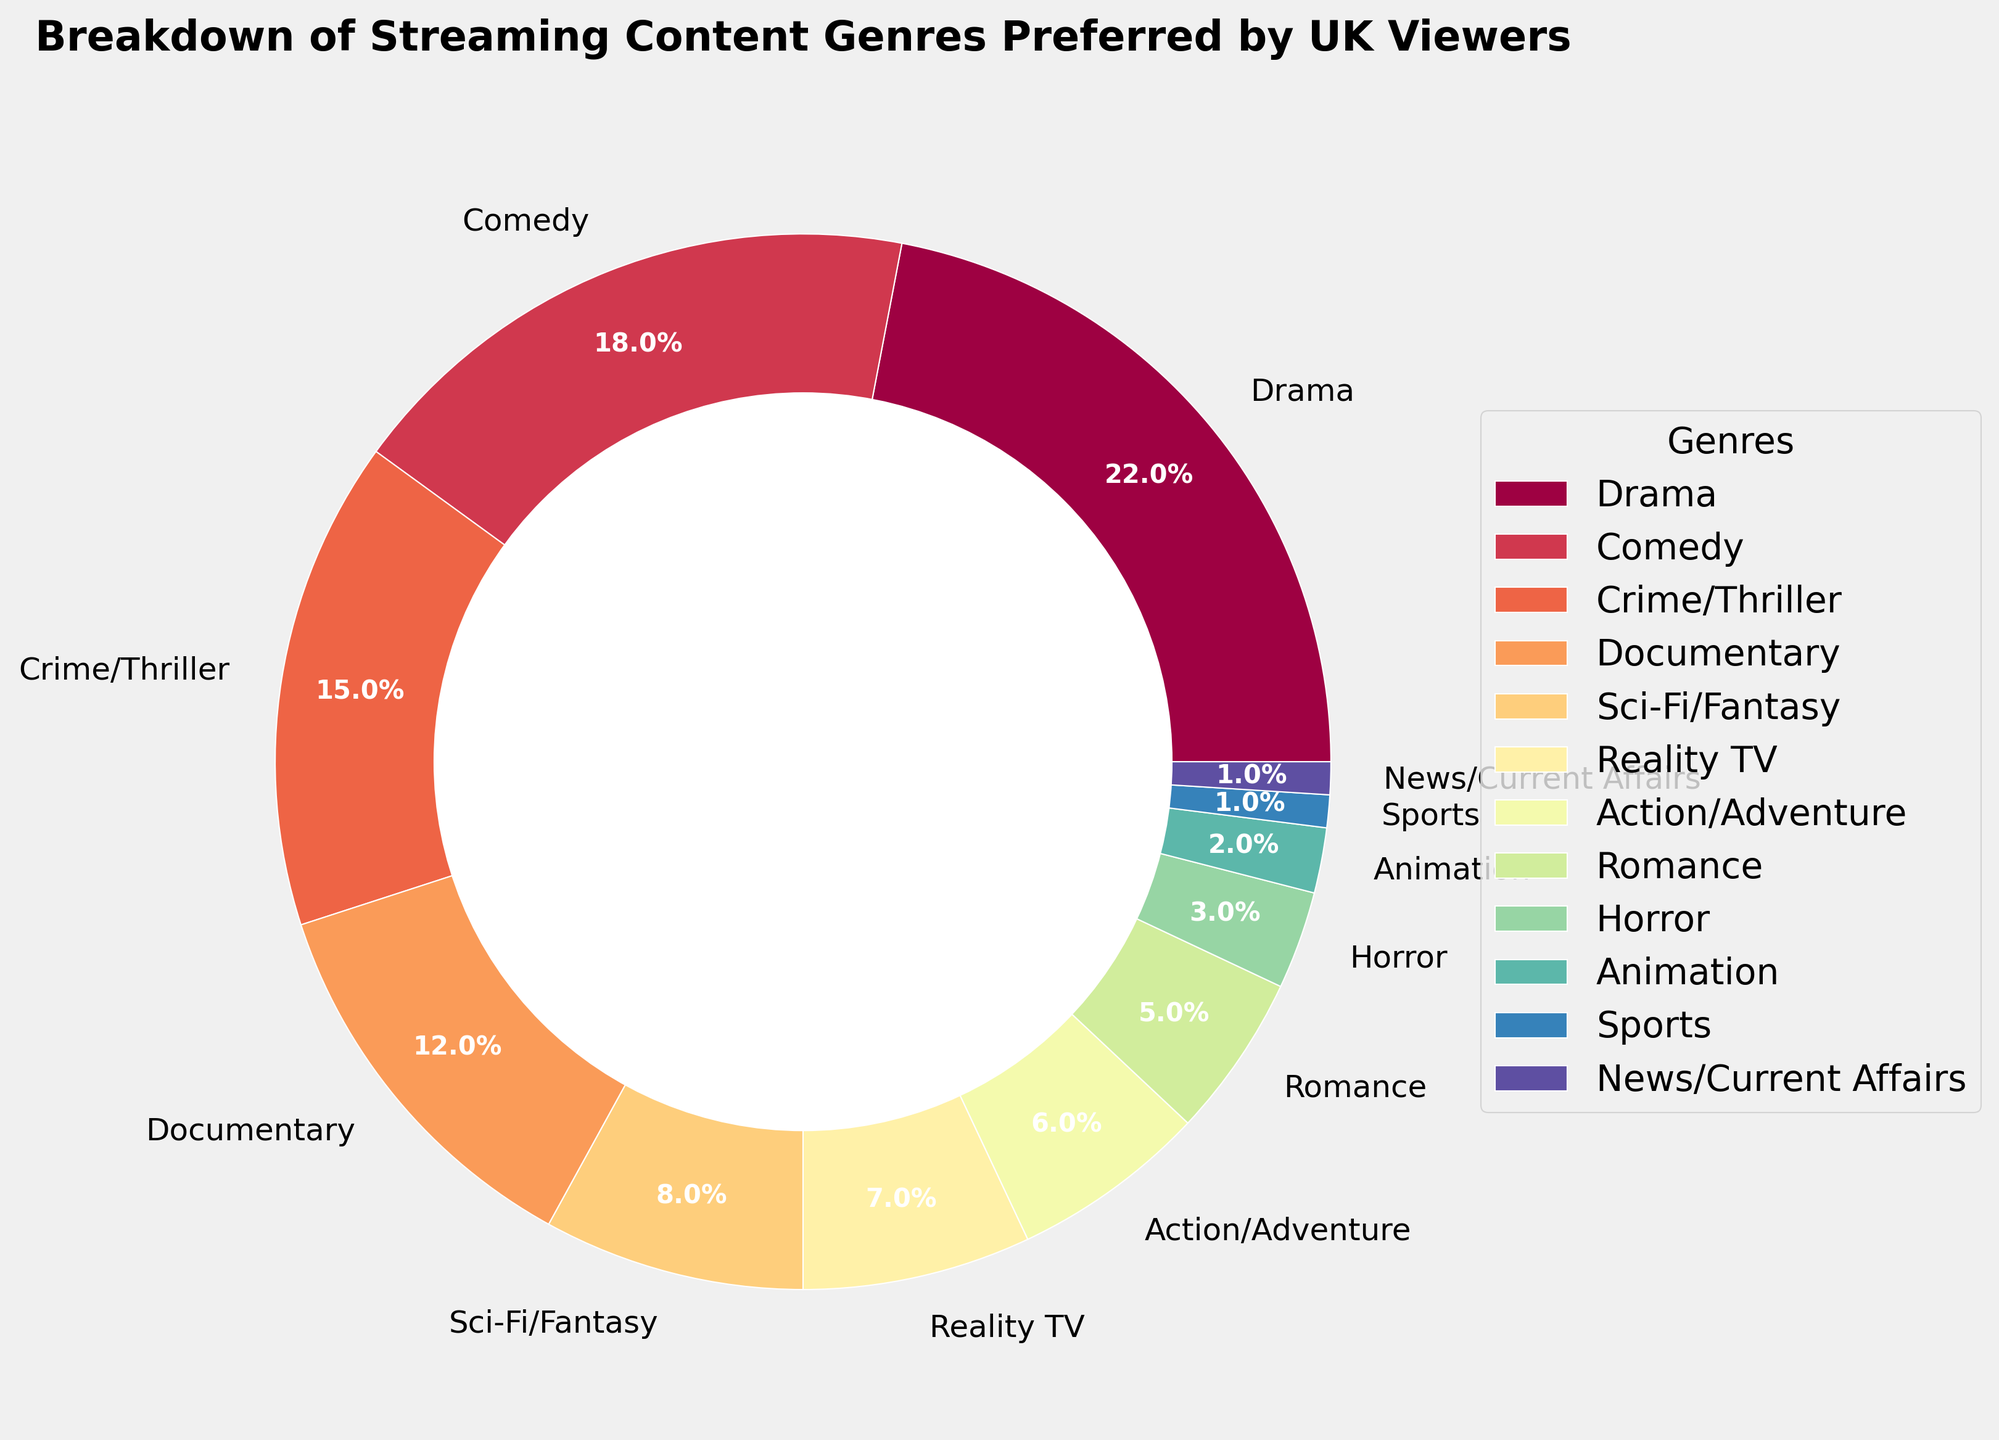What genre has the highest preference among UK viewers? To find the genre with the highest preference, look for the largest wedge in the pie chart and confirm its percentage. The largest wedge represents Drama with 22%.
Answer: Drama Which genres have a combined preference of over 30%? Add the percentages of the top genres until the sum exceeds 30%. Drama (22%) + Comedy (18%) = 40%, which is above 30%.
Answer: Drama and Comedy How much more popular is Drama compared to Romance? Subtract the percentage of Romance from the percentage of Drama. Drama is 22% while Romance is 5%, so 22% - 5% = 17%.
Answer: 17% Have Documentaries and Crime/Thriller combined a higher preference than Comedy? Add the percentages of Documentaries and Crime/Thriller, then compare the sum to Comedy's percentage. Documentaries (12%) + Crime/Thriller (15%) = 27%, which is higher than Comedy's 18%.
Answer: Yes What's the combined percentage of the least popular genres (Sports and News/Current Affairs)? Add the percentages of Sports and News/Current Affairs. Both have 1%, so the combined percentage is 1% + 1% = 2%.
Answer: 2% Which genre has a preference closest to that of Sci-Fi/Fantasy? Identify the percentage of Sci-Fi/Fantasy and find the genre with a percentage closest to this value. Sci-Fi/Fantasy is at 8%, and the closest is Reality TV at 7%.
Answer: Reality TV If you combine Action/Adventure and Horror, how does their combined preference compare to that of Documentary? Add the percentages of Action/Adventure and Horror, then compare the sum to Documentary. Action/Adventure (6%) + Horror (3%) = 9%, which is less than Documentary's 12%.
Answer: Less How much more popular are Comedy and Crime/Thriller combined than Reality TV? Add the percentages of Comedy and Crime/Thriller, then subtract Reality TV's percentage from the sum. Comedy (18%) + Crime/Thriller (15%) = 33%, and Reality TV is 7%. So, 33% - 7% = 26%.
Answer: 26% Which is less popular, Animation or Sci-Fi/Fantasy? Compare the percentages of Animation and Sci-Fi/Fantasy. Animation is 2% while Sci-Fi/Fantasy is 8%. Animation has the lower percentage.
Answer: Animation Which is the more preferred genre between Reality TV and Action/Adventure? Compare the percentages of Reality TV and Action/Adventure. Reality TV has 7% while Action/Adventure has 6%.
Answer: Reality TV 